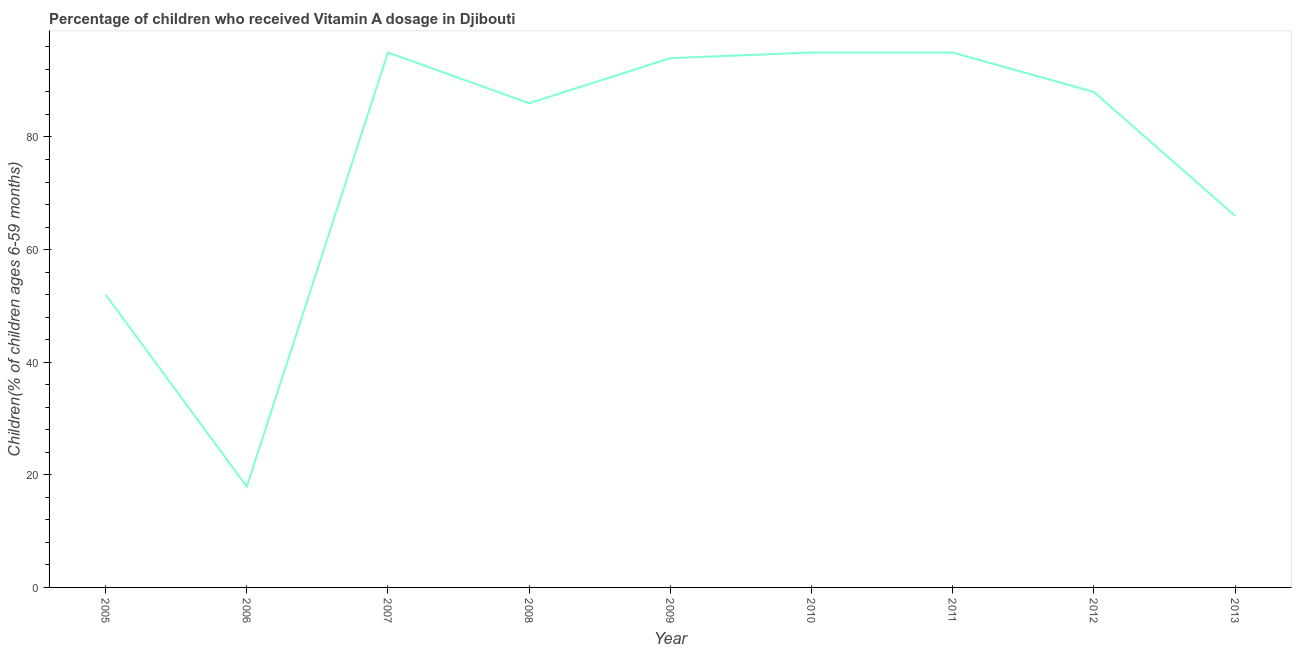What is the vitamin a supplementation coverage rate in 2009?
Provide a short and direct response. 94. Across all years, what is the maximum vitamin a supplementation coverage rate?
Make the answer very short. 95. Across all years, what is the minimum vitamin a supplementation coverage rate?
Provide a succinct answer. 17.9. In which year was the vitamin a supplementation coverage rate minimum?
Provide a short and direct response. 2006. What is the sum of the vitamin a supplementation coverage rate?
Keep it short and to the point. 688.9. What is the difference between the vitamin a supplementation coverage rate in 2005 and 2006?
Your response must be concise. 34.1. What is the average vitamin a supplementation coverage rate per year?
Make the answer very short. 76.54. What is the ratio of the vitamin a supplementation coverage rate in 2008 to that in 2013?
Make the answer very short. 1.3. What is the difference between the highest and the lowest vitamin a supplementation coverage rate?
Make the answer very short. 77.1. Does the vitamin a supplementation coverage rate monotonically increase over the years?
Your answer should be very brief. No. What is the difference between two consecutive major ticks on the Y-axis?
Make the answer very short. 20. Are the values on the major ticks of Y-axis written in scientific E-notation?
Offer a very short reply. No. Does the graph contain any zero values?
Offer a very short reply. No. What is the title of the graph?
Your answer should be very brief. Percentage of children who received Vitamin A dosage in Djibouti. What is the label or title of the Y-axis?
Your response must be concise. Children(% of children ages 6-59 months). What is the Children(% of children ages 6-59 months) in 2007?
Provide a succinct answer. 95. What is the Children(% of children ages 6-59 months) in 2008?
Your response must be concise. 86. What is the Children(% of children ages 6-59 months) in 2009?
Your response must be concise. 94. What is the difference between the Children(% of children ages 6-59 months) in 2005 and 2006?
Offer a very short reply. 34.1. What is the difference between the Children(% of children ages 6-59 months) in 2005 and 2007?
Your answer should be compact. -43. What is the difference between the Children(% of children ages 6-59 months) in 2005 and 2008?
Offer a very short reply. -34. What is the difference between the Children(% of children ages 6-59 months) in 2005 and 2009?
Provide a short and direct response. -42. What is the difference between the Children(% of children ages 6-59 months) in 2005 and 2010?
Make the answer very short. -43. What is the difference between the Children(% of children ages 6-59 months) in 2005 and 2011?
Offer a terse response. -43. What is the difference between the Children(% of children ages 6-59 months) in 2005 and 2012?
Offer a very short reply. -36. What is the difference between the Children(% of children ages 6-59 months) in 2005 and 2013?
Your answer should be compact. -14. What is the difference between the Children(% of children ages 6-59 months) in 2006 and 2007?
Make the answer very short. -77.1. What is the difference between the Children(% of children ages 6-59 months) in 2006 and 2008?
Provide a succinct answer. -68.1. What is the difference between the Children(% of children ages 6-59 months) in 2006 and 2009?
Provide a short and direct response. -76.1. What is the difference between the Children(% of children ages 6-59 months) in 2006 and 2010?
Make the answer very short. -77.1. What is the difference between the Children(% of children ages 6-59 months) in 2006 and 2011?
Give a very brief answer. -77.1. What is the difference between the Children(% of children ages 6-59 months) in 2006 and 2012?
Provide a succinct answer. -70.1. What is the difference between the Children(% of children ages 6-59 months) in 2006 and 2013?
Your answer should be compact. -48.1. What is the difference between the Children(% of children ages 6-59 months) in 2007 and 2011?
Your response must be concise. 0. What is the difference between the Children(% of children ages 6-59 months) in 2007 and 2012?
Make the answer very short. 7. What is the difference between the Children(% of children ages 6-59 months) in 2008 and 2011?
Provide a succinct answer. -9. What is the difference between the Children(% of children ages 6-59 months) in 2008 and 2013?
Provide a short and direct response. 20. What is the difference between the Children(% of children ages 6-59 months) in 2009 and 2013?
Offer a terse response. 28. What is the difference between the Children(% of children ages 6-59 months) in 2010 and 2011?
Your answer should be very brief. 0. What is the ratio of the Children(% of children ages 6-59 months) in 2005 to that in 2006?
Offer a terse response. 2.9. What is the ratio of the Children(% of children ages 6-59 months) in 2005 to that in 2007?
Keep it short and to the point. 0.55. What is the ratio of the Children(% of children ages 6-59 months) in 2005 to that in 2008?
Make the answer very short. 0.6. What is the ratio of the Children(% of children ages 6-59 months) in 2005 to that in 2009?
Offer a very short reply. 0.55. What is the ratio of the Children(% of children ages 6-59 months) in 2005 to that in 2010?
Make the answer very short. 0.55. What is the ratio of the Children(% of children ages 6-59 months) in 2005 to that in 2011?
Keep it short and to the point. 0.55. What is the ratio of the Children(% of children ages 6-59 months) in 2005 to that in 2012?
Keep it short and to the point. 0.59. What is the ratio of the Children(% of children ages 6-59 months) in 2005 to that in 2013?
Your answer should be compact. 0.79. What is the ratio of the Children(% of children ages 6-59 months) in 2006 to that in 2007?
Keep it short and to the point. 0.19. What is the ratio of the Children(% of children ages 6-59 months) in 2006 to that in 2008?
Offer a terse response. 0.21. What is the ratio of the Children(% of children ages 6-59 months) in 2006 to that in 2009?
Offer a very short reply. 0.19. What is the ratio of the Children(% of children ages 6-59 months) in 2006 to that in 2010?
Make the answer very short. 0.19. What is the ratio of the Children(% of children ages 6-59 months) in 2006 to that in 2011?
Your response must be concise. 0.19. What is the ratio of the Children(% of children ages 6-59 months) in 2006 to that in 2012?
Give a very brief answer. 0.2. What is the ratio of the Children(% of children ages 6-59 months) in 2006 to that in 2013?
Provide a succinct answer. 0.27. What is the ratio of the Children(% of children ages 6-59 months) in 2007 to that in 2008?
Ensure brevity in your answer.  1.1. What is the ratio of the Children(% of children ages 6-59 months) in 2007 to that in 2009?
Make the answer very short. 1.01. What is the ratio of the Children(% of children ages 6-59 months) in 2007 to that in 2010?
Keep it short and to the point. 1. What is the ratio of the Children(% of children ages 6-59 months) in 2007 to that in 2012?
Offer a terse response. 1.08. What is the ratio of the Children(% of children ages 6-59 months) in 2007 to that in 2013?
Keep it short and to the point. 1.44. What is the ratio of the Children(% of children ages 6-59 months) in 2008 to that in 2009?
Ensure brevity in your answer.  0.92. What is the ratio of the Children(% of children ages 6-59 months) in 2008 to that in 2010?
Your response must be concise. 0.91. What is the ratio of the Children(% of children ages 6-59 months) in 2008 to that in 2011?
Your answer should be very brief. 0.91. What is the ratio of the Children(% of children ages 6-59 months) in 2008 to that in 2013?
Offer a terse response. 1.3. What is the ratio of the Children(% of children ages 6-59 months) in 2009 to that in 2012?
Keep it short and to the point. 1.07. What is the ratio of the Children(% of children ages 6-59 months) in 2009 to that in 2013?
Ensure brevity in your answer.  1.42. What is the ratio of the Children(% of children ages 6-59 months) in 2010 to that in 2013?
Provide a short and direct response. 1.44. What is the ratio of the Children(% of children ages 6-59 months) in 2011 to that in 2013?
Your answer should be very brief. 1.44. What is the ratio of the Children(% of children ages 6-59 months) in 2012 to that in 2013?
Provide a succinct answer. 1.33. 